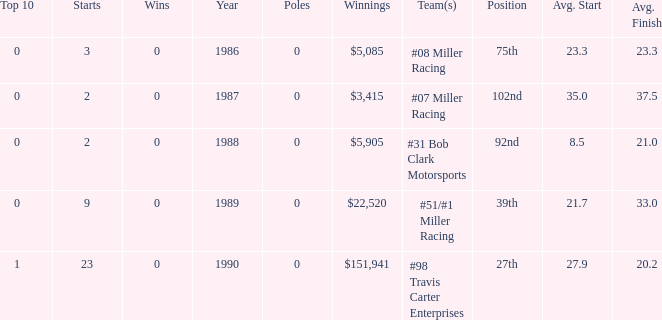What are the poles is #08 Miller racing? 0.0. 